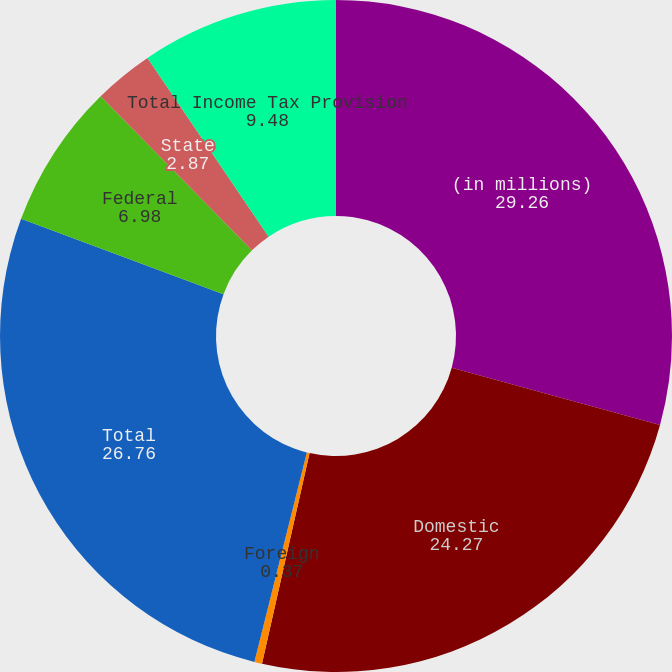Convert chart. <chart><loc_0><loc_0><loc_500><loc_500><pie_chart><fcel>(in millions)<fcel>Domestic<fcel>Foreign<fcel>Total<fcel>Federal<fcel>State<fcel>Total Income Tax Provision<nl><fcel>29.26%<fcel>24.27%<fcel>0.37%<fcel>26.76%<fcel>6.98%<fcel>2.87%<fcel>9.48%<nl></chart> 